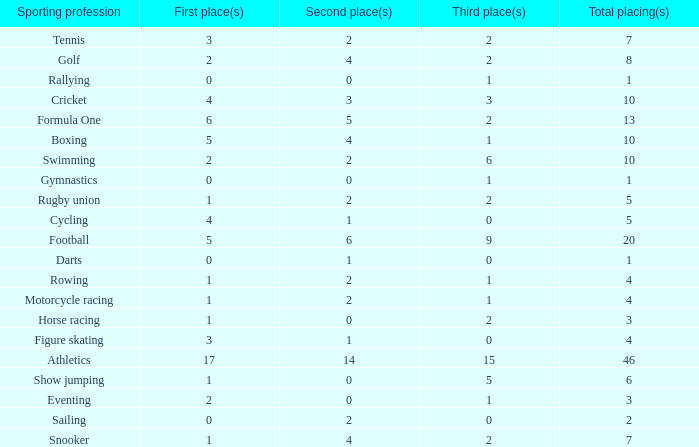How many second place showings does snooker have? 4.0. 